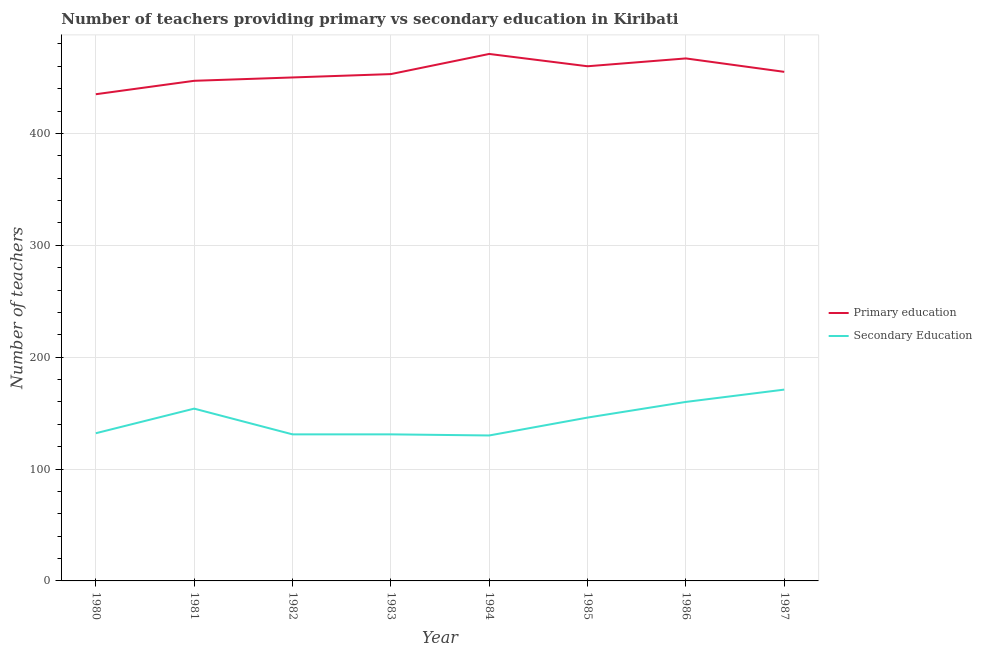How many different coloured lines are there?
Your answer should be very brief. 2. What is the number of primary teachers in 1987?
Provide a succinct answer. 455. Across all years, what is the maximum number of primary teachers?
Provide a short and direct response. 471. Across all years, what is the minimum number of primary teachers?
Make the answer very short. 435. In which year was the number of primary teachers maximum?
Keep it short and to the point. 1984. In which year was the number of primary teachers minimum?
Provide a short and direct response. 1980. What is the total number of primary teachers in the graph?
Ensure brevity in your answer.  3638. What is the difference between the number of secondary teachers in 1982 and that in 1986?
Your answer should be compact. -29. What is the difference between the number of primary teachers in 1986 and the number of secondary teachers in 1981?
Ensure brevity in your answer.  313. What is the average number of secondary teachers per year?
Give a very brief answer. 144.38. In the year 1984, what is the difference between the number of secondary teachers and number of primary teachers?
Offer a very short reply. -341. What is the ratio of the number of primary teachers in 1982 to that in 1985?
Your answer should be very brief. 0.98. Is the difference between the number of secondary teachers in 1980 and 1985 greater than the difference between the number of primary teachers in 1980 and 1985?
Provide a succinct answer. Yes. What is the difference between the highest and the second highest number of secondary teachers?
Offer a very short reply. 11. What is the difference between the highest and the lowest number of secondary teachers?
Ensure brevity in your answer.  41. In how many years, is the number of primary teachers greater than the average number of primary teachers taken over all years?
Ensure brevity in your answer.  4. Is the sum of the number of primary teachers in 1985 and 1987 greater than the maximum number of secondary teachers across all years?
Your response must be concise. Yes. Is the number of secondary teachers strictly greater than the number of primary teachers over the years?
Ensure brevity in your answer.  No. How many lines are there?
Make the answer very short. 2. How many years are there in the graph?
Your answer should be very brief. 8. What is the difference between two consecutive major ticks on the Y-axis?
Your response must be concise. 100. How many legend labels are there?
Make the answer very short. 2. What is the title of the graph?
Give a very brief answer. Number of teachers providing primary vs secondary education in Kiribati. Does "Registered firms" appear as one of the legend labels in the graph?
Offer a very short reply. No. What is the label or title of the Y-axis?
Give a very brief answer. Number of teachers. What is the Number of teachers of Primary education in 1980?
Ensure brevity in your answer.  435. What is the Number of teachers of Secondary Education in 1980?
Your answer should be compact. 132. What is the Number of teachers in Primary education in 1981?
Give a very brief answer. 447. What is the Number of teachers of Secondary Education in 1981?
Keep it short and to the point. 154. What is the Number of teachers in Primary education in 1982?
Ensure brevity in your answer.  450. What is the Number of teachers in Secondary Education in 1982?
Keep it short and to the point. 131. What is the Number of teachers of Primary education in 1983?
Provide a short and direct response. 453. What is the Number of teachers in Secondary Education in 1983?
Give a very brief answer. 131. What is the Number of teachers in Primary education in 1984?
Keep it short and to the point. 471. What is the Number of teachers in Secondary Education in 1984?
Offer a terse response. 130. What is the Number of teachers of Primary education in 1985?
Your response must be concise. 460. What is the Number of teachers of Secondary Education in 1985?
Provide a short and direct response. 146. What is the Number of teachers of Primary education in 1986?
Offer a very short reply. 467. What is the Number of teachers in Secondary Education in 1986?
Ensure brevity in your answer.  160. What is the Number of teachers in Primary education in 1987?
Your answer should be compact. 455. What is the Number of teachers of Secondary Education in 1987?
Provide a short and direct response. 171. Across all years, what is the maximum Number of teachers of Primary education?
Your response must be concise. 471. Across all years, what is the maximum Number of teachers of Secondary Education?
Provide a short and direct response. 171. Across all years, what is the minimum Number of teachers in Primary education?
Provide a short and direct response. 435. Across all years, what is the minimum Number of teachers in Secondary Education?
Provide a succinct answer. 130. What is the total Number of teachers in Primary education in the graph?
Your answer should be compact. 3638. What is the total Number of teachers in Secondary Education in the graph?
Your answer should be compact. 1155. What is the difference between the Number of teachers of Secondary Education in 1980 and that in 1981?
Your answer should be compact. -22. What is the difference between the Number of teachers in Primary education in 1980 and that in 1982?
Make the answer very short. -15. What is the difference between the Number of teachers in Secondary Education in 1980 and that in 1982?
Provide a succinct answer. 1. What is the difference between the Number of teachers of Primary education in 1980 and that in 1983?
Offer a terse response. -18. What is the difference between the Number of teachers in Primary education in 1980 and that in 1984?
Provide a short and direct response. -36. What is the difference between the Number of teachers of Secondary Education in 1980 and that in 1984?
Give a very brief answer. 2. What is the difference between the Number of teachers in Primary education in 1980 and that in 1985?
Keep it short and to the point. -25. What is the difference between the Number of teachers in Primary education in 1980 and that in 1986?
Provide a succinct answer. -32. What is the difference between the Number of teachers in Secondary Education in 1980 and that in 1986?
Your response must be concise. -28. What is the difference between the Number of teachers in Secondary Education in 1980 and that in 1987?
Keep it short and to the point. -39. What is the difference between the Number of teachers in Secondary Education in 1981 and that in 1982?
Ensure brevity in your answer.  23. What is the difference between the Number of teachers in Primary education in 1981 and that in 1983?
Your answer should be compact. -6. What is the difference between the Number of teachers in Secondary Education in 1981 and that in 1983?
Make the answer very short. 23. What is the difference between the Number of teachers of Primary education in 1981 and that in 1985?
Your answer should be compact. -13. What is the difference between the Number of teachers in Primary education in 1981 and that in 1986?
Offer a very short reply. -20. What is the difference between the Number of teachers in Secondary Education in 1981 and that in 1986?
Your answer should be very brief. -6. What is the difference between the Number of teachers of Secondary Education in 1981 and that in 1987?
Provide a succinct answer. -17. What is the difference between the Number of teachers of Secondary Education in 1982 and that in 1983?
Provide a short and direct response. 0. What is the difference between the Number of teachers of Secondary Education in 1982 and that in 1984?
Offer a terse response. 1. What is the difference between the Number of teachers of Secondary Education in 1982 and that in 1985?
Offer a terse response. -15. What is the difference between the Number of teachers of Secondary Education in 1983 and that in 1984?
Keep it short and to the point. 1. What is the difference between the Number of teachers of Primary education in 1983 and that in 1985?
Offer a terse response. -7. What is the difference between the Number of teachers in Secondary Education in 1983 and that in 1987?
Provide a succinct answer. -40. What is the difference between the Number of teachers of Primary education in 1984 and that in 1985?
Ensure brevity in your answer.  11. What is the difference between the Number of teachers in Secondary Education in 1984 and that in 1987?
Make the answer very short. -41. What is the difference between the Number of teachers in Primary education in 1985 and that in 1986?
Your response must be concise. -7. What is the difference between the Number of teachers of Primary education in 1985 and that in 1987?
Give a very brief answer. 5. What is the difference between the Number of teachers in Secondary Education in 1985 and that in 1987?
Offer a very short reply. -25. What is the difference between the Number of teachers in Secondary Education in 1986 and that in 1987?
Ensure brevity in your answer.  -11. What is the difference between the Number of teachers of Primary education in 1980 and the Number of teachers of Secondary Education in 1981?
Offer a terse response. 281. What is the difference between the Number of teachers in Primary education in 1980 and the Number of teachers in Secondary Education in 1982?
Your answer should be compact. 304. What is the difference between the Number of teachers of Primary education in 1980 and the Number of teachers of Secondary Education in 1983?
Give a very brief answer. 304. What is the difference between the Number of teachers in Primary education in 1980 and the Number of teachers in Secondary Education in 1984?
Make the answer very short. 305. What is the difference between the Number of teachers in Primary education in 1980 and the Number of teachers in Secondary Education in 1985?
Give a very brief answer. 289. What is the difference between the Number of teachers in Primary education in 1980 and the Number of teachers in Secondary Education in 1986?
Offer a very short reply. 275. What is the difference between the Number of teachers in Primary education in 1980 and the Number of teachers in Secondary Education in 1987?
Your answer should be compact. 264. What is the difference between the Number of teachers of Primary education in 1981 and the Number of teachers of Secondary Education in 1982?
Provide a short and direct response. 316. What is the difference between the Number of teachers in Primary education in 1981 and the Number of teachers in Secondary Education in 1983?
Your answer should be very brief. 316. What is the difference between the Number of teachers in Primary education in 1981 and the Number of teachers in Secondary Education in 1984?
Make the answer very short. 317. What is the difference between the Number of teachers in Primary education in 1981 and the Number of teachers in Secondary Education in 1985?
Provide a short and direct response. 301. What is the difference between the Number of teachers in Primary education in 1981 and the Number of teachers in Secondary Education in 1986?
Your answer should be compact. 287. What is the difference between the Number of teachers of Primary education in 1981 and the Number of teachers of Secondary Education in 1987?
Make the answer very short. 276. What is the difference between the Number of teachers of Primary education in 1982 and the Number of teachers of Secondary Education in 1983?
Provide a short and direct response. 319. What is the difference between the Number of teachers in Primary education in 1982 and the Number of teachers in Secondary Education in 1984?
Ensure brevity in your answer.  320. What is the difference between the Number of teachers of Primary education in 1982 and the Number of teachers of Secondary Education in 1985?
Keep it short and to the point. 304. What is the difference between the Number of teachers in Primary education in 1982 and the Number of teachers in Secondary Education in 1986?
Provide a short and direct response. 290. What is the difference between the Number of teachers in Primary education in 1982 and the Number of teachers in Secondary Education in 1987?
Offer a very short reply. 279. What is the difference between the Number of teachers in Primary education in 1983 and the Number of teachers in Secondary Education in 1984?
Provide a short and direct response. 323. What is the difference between the Number of teachers of Primary education in 1983 and the Number of teachers of Secondary Education in 1985?
Your answer should be very brief. 307. What is the difference between the Number of teachers in Primary education in 1983 and the Number of teachers in Secondary Education in 1986?
Offer a terse response. 293. What is the difference between the Number of teachers in Primary education in 1983 and the Number of teachers in Secondary Education in 1987?
Provide a short and direct response. 282. What is the difference between the Number of teachers of Primary education in 1984 and the Number of teachers of Secondary Education in 1985?
Your response must be concise. 325. What is the difference between the Number of teachers of Primary education in 1984 and the Number of teachers of Secondary Education in 1986?
Offer a terse response. 311. What is the difference between the Number of teachers of Primary education in 1984 and the Number of teachers of Secondary Education in 1987?
Give a very brief answer. 300. What is the difference between the Number of teachers of Primary education in 1985 and the Number of teachers of Secondary Education in 1986?
Make the answer very short. 300. What is the difference between the Number of teachers in Primary education in 1985 and the Number of teachers in Secondary Education in 1987?
Offer a very short reply. 289. What is the difference between the Number of teachers of Primary education in 1986 and the Number of teachers of Secondary Education in 1987?
Offer a very short reply. 296. What is the average Number of teachers in Primary education per year?
Offer a very short reply. 454.75. What is the average Number of teachers in Secondary Education per year?
Provide a short and direct response. 144.38. In the year 1980, what is the difference between the Number of teachers in Primary education and Number of teachers in Secondary Education?
Offer a very short reply. 303. In the year 1981, what is the difference between the Number of teachers in Primary education and Number of teachers in Secondary Education?
Provide a short and direct response. 293. In the year 1982, what is the difference between the Number of teachers of Primary education and Number of teachers of Secondary Education?
Your response must be concise. 319. In the year 1983, what is the difference between the Number of teachers of Primary education and Number of teachers of Secondary Education?
Make the answer very short. 322. In the year 1984, what is the difference between the Number of teachers in Primary education and Number of teachers in Secondary Education?
Your response must be concise. 341. In the year 1985, what is the difference between the Number of teachers in Primary education and Number of teachers in Secondary Education?
Offer a very short reply. 314. In the year 1986, what is the difference between the Number of teachers in Primary education and Number of teachers in Secondary Education?
Keep it short and to the point. 307. In the year 1987, what is the difference between the Number of teachers in Primary education and Number of teachers in Secondary Education?
Keep it short and to the point. 284. What is the ratio of the Number of teachers of Primary education in 1980 to that in 1981?
Your answer should be compact. 0.97. What is the ratio of the Number of teachers in Primary education in 1980 to that in 1982?
Ensure brevity in your answer.  0.97. What is the ratio of the Number of teachers of Secondary Education in 1980 to that in 1982?
Your answer should be compact. 1.01. What is the ratio of the Number of teachers in Primary education in 1980 to that in 1983?
Make the answer very short. 0.96. What is the ratio of the Number of teachers in Secondary Education in 1980 to that in 1983?
Provide a succinct answer. 1.01. What is the ratio of the Number of teachers of Primary education in 1980 to that in 1984?
Keep it short and to the point. 0.92. What is the ratio of the Number of teachers of Secondary Education in 1980 to that in 1984?
Offer a very short reply. 1.02. What is the ratio of the Number of teachers in Primary education in 1980 to that in 1985?
Ensure brevity in your answer.  0.95. What is the ratio of the Number of teachers in Secondary Education in 1980 to that in 1985?
Your response must be concise. 0.9. What is the ratio of the Number of teachers in Primary education in 1980 to that in 1986?
Offer a very short reply. 0.93. What is the ratio of the Number of teachers of Secondary Education in 1980 to that in 1986?
Ensure brevity in your answer.  0.82. What is the ratio of the Number of teachers in Primary education in 1980 to that in 1987?
Your response must be concise. 0.96. What is the ratio of the Number of teachers of Secondary Education in 1980 to that in 1987?
Your response must be concise. 0.77. What is the ratio of the Number of teachers of Secondary Education in 1981 to that in 1982?
Your answer should be compact. 1.18. What is the ratio of the Number of teachers of Secondary Education in 1981 to that in 1983?
Your answer should be compact. 1.18. What is the ratio of the Number of teachers of Primary education in 1981 to that in 1984?
Give a very brief answer. 0.95. What is the ratio of the Number of teachers of Secondary Education in 1981 to that in 1984?
Offer a very short reply. 1.18. What is the ratio of the Number of teachers in Primary education in 1981 to that in 1985?
Offer a terse response. 0.97. What is the ratio of the Number of teachers of Secondary Education in 1981 to that in 1985?
Provide a short and direct response. 1.05. What is the ratio of the Number of teachers of Primary education in 1981 to that in 1986?
Your answer should be compact. 0.96. What is the ratio of the Number of teachers in Secondary Education in 1981 to that in 1986?
Your answer should be compact. 0.96. What is the ratio of the Number of teachers of Primary education in 1981 to that in 1987?
Offer a terse response. 0.98. What is the ratio of the Number of teachers in Secondary Education in 1981 to that in 1987?
Keep it short and to the point. 0.9. What is the ratio of the Number of teachers of Secondary Education in 1982 to that in 1983?
Your answer should be very brief. 1. What is the ratio of the Number of teachers of Primary education in 1982 to that in 1984?
Provide a short and direct response. 0.96. What is the ratio of the Number of teachers of Secondary Education in 1982 to that in 1984?
Make the answer very short. 1.01. What is the ratio of the Number of teachers in Primary education in 1982 to that in 1985?
Your response must be concise. 0.98. What is the ratio of the Number of teachers of Secondary Education in 1982 to that in 1985?
Give a very brief answer. 0.9. What is the ratio of the Number of teachers of Primary education in 1982 to that in 1986?
Offer a terse response. 0.96. What is the ratio of the Number of teachers in Secondary Education in 1982 to that in 1986?
Ensure brevity in your answer.  0.82. What is the ratio of the Number of teachers in Primary education in 1982 to that in 1987?
Make the answer very short. 0.99. What is the ratio of the Number of teachers of Secondary Education in 1982 to that in 1987?
Offer a very short reply. 0.77. What is the ratio of the Number of teachers in Primary education in 1983 to that in 1984?
Keep it short and to the point. 0.96. What is the ratio of the Number of teachers of Secondary Education in 1983 to that in 1984?
Provide a succinct answer. 1.01. What is the ratio of the Number of teachers in Secondary Education in 1983 to that in 1985?
Ensure brevity in your answer.  0.9. What is the ratio of the Number of teachers of Primary education in 1983 to that in 1986?
Offer a very short reply. 0.97. What is the ratio of the Number of teachers in Secondary Education in 1983 to that in 1986?
Provide a succinct answer. 0.82. What is the ratio of the Number of teachers in Primary education in 1983 to that in 1987?
Your response must be concise. 1. What is the ratio of the Number of teachers in Secondary Education in 1983 to that in 1987?
Make the answer very short. 0.77. What is the ratio of the Number of teachers of Primary education in 1984 to that in 1985?
Your response must be concise. 1.02. What is the ratio of the Number of teachers in Secondary Education in 1984 to that in 1985?
Offer a very short reply. 0.89. What is the ratio of the Number of teachers of Primary education in 1984 to that in 1986?
Your response must be concise. 1.01. What is the ratio of the Number of teachers of Secondary Education in 1984 to that in 1986?
Make the answer very short. 0.81. What is the ratio of the Number of teachers in Primary education in 1984 to that in 1987?
Make the answer very short. 1.04. What is the ratio of the Number of teachers of Secondary Education in 1984 to that in 1987?
Your answer should be compact. 0.76. What is the ratio of the Number of teachers in Secondary Education in 1985 to that in 1986?
Give a very brief answer. 0.91. What is the ratio of the Number of teachers in Secondary Education in 1985 to that in 1987?
Your answer should be very brief. 0.85. What is the ratio of the Number of teachers in Primary education in 1986 to that in 1987?
Make the answer very short. 1.03. What is the ratio of the Number of teachers of Secondary Education in 1986 to that in 1987?
Make the answer very short. 0.94. What is the difference between the highest and the second highest Number of teachers of Primary education?
Provide a succinct answer. 4. What is the difference between the highest and the second highest Number of teachers in Secondary Education?
Offer a terse response. 11. 